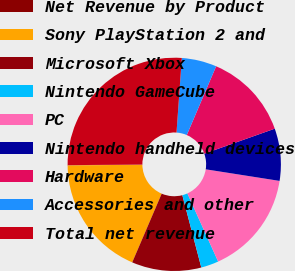Convert chart to OTSL. <chart><loc_0><loc_0><loc_500><loc_500><pie_chart><fcel>Net Revenue by Product<fcel>Sony PlayStation 2 and<fcel>Microsoft Xbox<fcel>Nintendo GameCube<fcel>PC<fcel>Nintendo handheld devices<fcel>Hardware<fcel>Accessories and other<fcel>Total net revenue<nl><fcel>0.05%<fcel>18.39%<fcel>10.53%<fcel>2.67%<fcel>15.77%<fcel>7.91%<fcel>13.15%<fcel>5.29%<fcel>26.25%<nl></chart> 